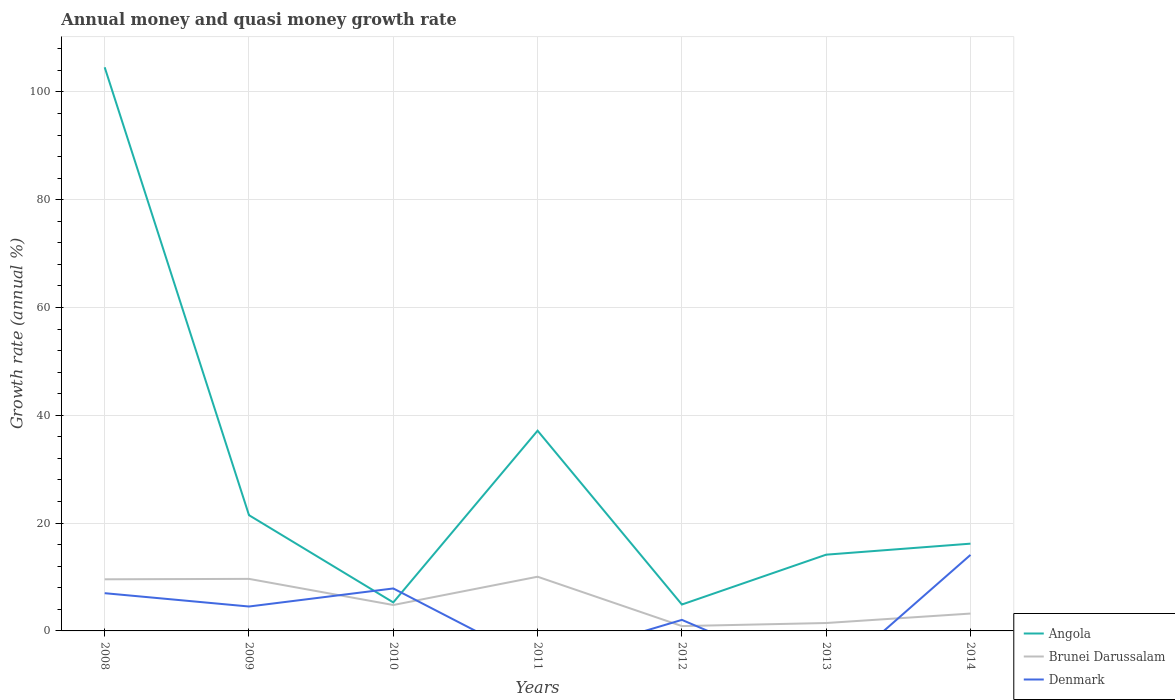Does the line corresponding to Brunei Darussalam intersect with the line corresponding to Angola?
Offer a very short reply. No. Is the number of lines equal to the number of legend labels?
Make the answer very short. No. Across all years, what is the maximum growth rate in Brunei Darussalam?
Your response must be concise. 0.9. What is the total growth rate in Angola in the graph?
Give a very brief answer. -11.29. What is the difference between the highest and the second highest growth rate in Brunei Darussalam?
Provide a short and direct response. 9.16. Is the growth rate in Denmark strictly greater than the growth rate in Angola over the years?
Provide a succinct answer. No. Does the graph contain any zero values?
Keep it short and to the point. Yes. Does the graph contain grids?
Keep it short and to the point. Yes. How are the legend labels stacked?
Offer a very short reply. Vertical. What is the title of the graph?
Offer a terse response. Annual money and quasi money growth rate. Does "Ukraine" appear as one of the legend labels in the graph?
Give a very brief answer. No. What is the label or title of the Y-axis?
Keep it short and to the point. Growth rate (annual %). What is the Growth rate (annual %) in Angola in 2008?
Provide a short and direct response. 104.57. What is the Growth rate (annual %) in Brunei Darussalam in 2008?
Your answer should be compact. 9.58. What is the Growth rate (annual %) in Denmark in 2008?
Provide a short and direct response. 7. What is the Growth rate (annual %) of Angola in 2009?
Offer a terse response. 21.48. What is the Growth rate (annual %) of Brunei Darussalam in 2009?
Make the answer very short. 9.66. What is the Growth rate (annual %) in Denmark in 2009?
Your answer should be compact. 4.53. What is the Growth rate (annual %) of Angola in 2010?
Offer a terse response. 5.29. What is the Growth rate (annual %) in Brunei Darussalam in 2010?
Keep it short and to the point. 4.81. What is the Growth rate (annual %) in Denmark in 2010?
Your answer should be compact. 7.88. What is the Growth rate (annual %) in Angola in 2011?
Offer a terse response. 37.15. What is the Growth rate (annual %) of Brunei Darussalam in 2011?
Your answer should be very brief. 10.05. What is the Growth rate (annual %) in Angola in 2012?
Your answer should be compact. 4.9. What is the Growth rate (annual %) in Brunei Darussalam in 2012?
Your response must be concise. 0.9. What is the Growth rate (annual %) in Denmark in 2012?
Your response must be concise. 2.05. What is the Growth rate (annual %) in Angola in 2013?
Offer a terse response. 14.15. What is the Growth rate (annual %) in Brunei Darussalam in 2013?
Provide a short and direct response. 1.47. What is the Growth rate (annual %) of Denmark in 2013?
Give a very brief answer. 0. What is the Growth rate (annual %) in Angola in 2014?
Ensure brevity in your answer.  16.19. What is the Growth rate (annual %) in Brunei Darussalam in 2014?
Provide a succinct answer. 3.22. What is the Growth rate (annual %) in Denmark in 2014?
Your answer should be compact. 14.1. Across all years, what is the maximum Growth rate (annual %) of Angola?
Your answer should be very brief. 104.57. Across all years, what is the maximum Growth rate (annual %) in Brunei Darussalam?
Ensure brevity in your answer.  10.05. Across all years, what is the maximum Growth rate (annual %) of Denmark?
Offer a very short reply. 14.1. Across all years, what is the minimum Growth rate (annual %) of Angola?
Your answer should be compact. 4.9. Across all years, what is the minimum Growth rate (annual %) of Brunei Darussalam?
Keep it short and to the point. 0.9. Across all years, what is the minimum Growth rate (annual %) of Denmark?
Give a very brief answer. 0. What is the total Growth rate (annual %) in Angola in the graph?
Offer a terse response. 203.71. What is the total Growth rate (annual %) in Brunei Darussalam in the graph?
Your response must be concise. 39.68. What is the total Growth rate (annual %) of Denmark in the graph?
Provide a short and direct response. 35.56. What is the difference between the Growth rate (annual %) in Angola in 2008 and that in 2009?
Offer a terse response. 83.09. What is the difference between the Growth rate (annual %) of Brunei Darussalam in 2008 and that in 2009?
Your answer should be compact. -0.08. What is the difference between the Growth rate (annual %) of Denmark in 2008 and that in 2009?
Your response must be concise. 2.47. What is the difference between the Growth rate (annual %) of Angola in 2008 and that in 2010?
Offer a terse response. 99.28. What is the difference between the Growth rate (annual %) in Brunei Darussalam in 2008 and that in 2010?
Offer a very short reply. 4.77. What is the difference between the Growth rate (annual %) of Denmark in 2008 and that in 2010?
Provide a succinct answer. -0.88. What is the difference between the Growth rate (annual %) in Angola in 2008 and that in 2011?
Offer a terse response. 67.42. What is the difference between the Growth rate (annual %) in Brunei Darussalam in 2008 and that in 2011?
Provide a succinct answer. -0.48. What is the difference between the Growth rate (annual %) in Angola in 2008 and that in 2012?
Offer a terse response. 99.67. What is the difference between the Growth rate (annual %) of Brunei Darussalam in 2008 and that in 2012?
Provide a succinct answer. 8.68. What is the difference between the Growth rate (annual %) in Denmark in 2008 and that in 2012?
Ensure brevity in your answer.  4.95. What is the difference between the Growth rate (annual %) in Angola in 2008 and that in 2013?
Your response must be concise. 90.42. What is the difference between the Growth rate (annual %) in Brunei Darussalam in 2008 and that in 2013?
Your answer should be very brief. 8.11. What is the difference between the Growth rate (annual %) in Angola in 2008 and that in 2014?
Give a very brief answer. 88.38. What is the difference between the Growth rate (annual %) of Brunei Darussalam in 2008 and that in 2014?
Keep it short and to the point. 6.36. What is the difference between the Growth rate (annual %) of Denmark in 2008 and that in 2014?
Give a very brief answer. -7.1. What is the difference between the Growth rate (annual %) of Angola in 2009 and that in 2010?
Ensure brevity in your answer.  16.19. What is the difference between the Growth rate (annual %) in Brunei Darussalam in 2009 and that in 2010?
Offer a very short reply. 4.85. What is the difference between the Growth rate (annual %) of Denmark in 2009 and that in 2010?
Provide a succinct answer. -3.35. What is the difference between the Growth rate (annual %) in Angola in 2009 and that in 2011?
Offer a very short reply. -15.67. What is the difference between the Growth rate (annual %) of Brunei Darussalam in 2009 and that in 2011?
Keep it short and to the point. -0.4. What is the difference between the Growth rate (annual %) of Angola in 2009 and that in 2012?
Provide a succinct answer. 16.58. What is the difference between the Growth rate (annual %) in Brunei Darussalam in 2009 and that in 2012?
Keep it short and to the point. 8.76. What is the difference between the Growth rate (annual %) of Denmark in 2009 and that in 2012?
Your response must be concise. 2.48. What is the difference between the Growth rate (annual %) of Angola in 2009 and that in 2013?
Your response must be concise. 7.33. What is the difference between the Growth rate (annual %) of Brunei Darussalam in 2009 and that in 2013?
Your answer should be very brief. 8.19. What is the difference between the Growth rate (annual %) in Angola in 2009 and that in 2014?
Ensure brevity in your answer.  5.29. What is the difference between the Growth rate (annual %) in Brunei Darussalam in 2009 and that in 2014?
Offer a terse response. 6.43. What is the difference between the Growth rate (annual %) in Denmark in 2009 and that in 2014?
Give a very brief answer. -9.57. What is the difference between the Growth rate (annual %) in Angola in 2010 and that in 2011?
Provide a succinct answer. -31.86. What is the difference between the Growth rate (annual %) of Brunei Darussalam in 2010 and that in 2011?
Give a very brief answer. -5.25. What is the difference between the Growth rate (annual %) of Angola in 2010 and that in 2012?
Provide a succinct answer. 0.39. What is the difference between the Growth rate (annual %) of Brunei Darussalam in 2010 and that in 2012?
Provide a short and direct response. 3.91. What is the difference between the Growth rate (annual %) in Denmark in 2010 and that in 2012?
Give a very brief answer. 5.83. What is the difference between the Growth rate (annual %) of Angola in 2010 and that in 2013?
Offer a terse response. -8.86. What is the difference between the Growth rate (annual %) in Brunei Darussalam in 2010 and that in 2013?
Your response must be concise. 3.34. What is the difference between the Growth rate (annual %) in Angola in 2010 and that in 2014?
Offer a very short reply. -10.9. What is the difference between the Growth rate (annual %) of Brunei Darussalam in 2010 and that in 2014?
Your answer should be very brief. 1.59. What is the difference between the Growth rate (annual %) in Denmark in 2010 and that in 2014?
Ensure brevity in your answer.  -6.22. What is the difference between the Growth rate (annual %) of Angola in 2011 and that in 2012?
Ensure brevity in your answer.  32.25. What is the difference between the Growth rate (annual %) in Brunei Darussalam in 2011 and that in 2012?
Your response must be concise. 9.16. What is the difference between the Growth rate (annual %) of Angola in 2011 and that in 2013?
Your response must be concise. 23. What is the difference between the Growth rate (annual %) of Brunei Darussalam in 2011 and that in 2013?
Your answer should be very brief. 8.59. What is the difference between the Growth rate (annual %) in Angola in 2011 and that in 2014?
Give a very brief answer. 20.96. What is the difference between the Growth rate (annual %) of Brunei Darussalam in 2011 and that in 2014?
Your answer should be very brief. 6.83. What is the difference between the Growth rate (annual %) of Angola in 2012 and that in 2013?
Give a very brief answer. -9.25. What is the difference between the Growth rate (annual %) in Brunei Darussalam in 2012 and that in 2013?
Provide a succinct answer. -0.57. What is the difference between the Growth rate (annual %) in Angola in 2012 and that in 2014?
Give a very brief answer. -11.29. What is the difference between the Growth rate (annual %) of Brunei Darussalam in 2012 and that in 2014?
Your answer should be very brief. -2.32. What is the difference between the Growth rate (annual %) of Denmark in 2012 and that in 2014?
Your answer should be very brief. -12.05. What is the difference between the Growth rate (annual %) in Angola in 2013 and that in 2014?
Offer a terse response. -2.04. What is the difference between the Growth rate (annual %) in Brunei Darussalam in 2013 and that in 2014?
Provide a succinct answer. -1.75. What is the difference between the Growth rate (annual %) in Angola in 2008 and the Growth rate (annual %) in Brunei Darussalam in 2009?
Ensure brevity in your answer.  94.91. What is the difference between the Growth rate (annual %) of Angola in 2008 and the Growth rate (annual %) of Denmark in 2009?
Provide a short and direct response. 100.04. What is the difference between the Growth rate (annual %) of Brunei Darussalam in 2008 and the Growth rate (annual %) of Denmark in 2009?
Your answer should be very brief. 5.05. What is the difference between the Growth rate (annual %) in Angola in 2008 and the Growth rate (annual %) in Brunei Darussalam in 2010?
Your answer should be very brief. 99.76. What is the difference between the Growth rate (annual %) of Angola in 2008 and the Growth rate (annual %) of Denmark in 2010?
Provide a succinct answer. 96.69. What is the difference between the Growth rate (annual %) in Brunei Darussalam in 2008 and the Growth rate (annual %) in Denmark in 2010?
Offer a very short reply. 1.7. What is the difference between the Growth rate (annual %) in Angola in 2008 and the Growth rate (annual %) in Brunei Darussalam in 2011?
Give a very brief answer. 94.51. What is the difference between the Growth rate (annual %) in Angola in 2008 and the Growth rate (annual %) in Brunei Darussalam in 2012?
Provide a succinct answer. 103.67. What is the difference between the Growth rate (annual %) of Angola in 2008 and the Growth rate (annual %) of Denmark in 2012?
Ensure brevity in your answer.  102.52. What is the difference between the Growth rate (annual %) of Brunei Darussalam in 2008 and the Growth rate (annual %) of Denmark in 2012?
Keep it short and to the point. 7.53. What is the difference between the Growth rate (annual %) in Angola in 2008 and the Growth rate (annual %) in Brunei Darussalam in 2013?
Offer a very short reply. 103.1. What is the difference between the Growth rate (annual %) of Angola in 2008 and the Growth rate (annual %) of Brunei Darussalam in 2014?
Your answer should be very brief. 101.34. What is the difference between the Growth rate (annual %) of Angola in 2008 and the Growth rate (annual %) of Denmark in 2014?
Provide a succinct answer. 90.46. What is the difference between the Growth rate (annual %) in Brunei Darussalam in 2008 and the Growth rate (annual %) in Denmark in 2014?
Your answer should be compact. -4.52. What is the difference between the Growth rate (annual %) in Angola in 2009 and the Growth rate (annual %) in Brunei Darussalam in 2010?
Make the answer very short. 16.67. What is the difference between the Growth rate (annual %) in Angola in 2009 and the Growth rate (annual %) in Denmark in 2010?
Your answer should be very brief. 13.6. What is the difference between the Growth rate (annual %) of Brunei Darussalam in 2009 and the Growth rate (annual %) of Denmark in 2010?
Your response must be concise. 1.78. What is the difference between the Growth rate (annual %) of Angola in 2009 and the Growth rate (annual %) of Brunei Darussalam in 2011?
Ensure brevity in your answer.  11.42. What is the difference between the Growth rate (annual %) in Angola in 2009 and the Growth rate (annual %) in Brunei Darussalam in 2012?
Make the answer very short. 20.58. What is the difference between the Growth rate (annual %) in Angola in 2009 and the Growth rate (annual %) in Denmark in 2012?
Your response must be concise. 19.43. What is the difference between the Growth rate (annual %) of Brunei Darussalam in 2009 and the Growth rate (annual %) of Denmark in 2012?
Offer a very short reply. 7.61. What is the difference between the Growth rate (annual %) in Angola in 2009 and the Growth rate (annual %) in Brunei Darussalam in 2013?
Provide a short and direct response. 20.01. What is the difference between the Growth rate (annual %) of Angola in 2009 and the Growth rate (annual %) of Brunei Darussalam in 2014?
Give a very brief answer. 18.25. What is the difference between the Growth rate (annual %) in Angola in 2009 and the Growth rate (annual %) in Denmark in 2014?
Make the answer very short. 7.37. What is the difference between the Growth rate (annual %) of Brunei Darussalam in 2009 and the Growth rate (annual %) of Denmark in 2014?
Provide a succinct answer. -4.45. What is the difference between the Growth rate (annual %) in Angola in 2010 and the Growth rate (annual %) in Brunei Darussalam in 2011?
Offer a very short reply. -4.77. What is the difference between the Growth rate (annual %) of Angola in 2010 and the Growth rate (annual %) of Brunei Darussalam in 2012?
Make the answer very short. 4.39. What is the difference between the Growth rate (annual %) of Angola in 2010 and the Growth rate (annual %) of Denmark in 2012?
Your response must be concise. 3.24. What is the difference between the Growth rate (annual %) of Brunei Darussalam in 2010 and the Growth rate (annual %) of Denmark in 2012?
Offer a terse response. 2.76. What is the difference between the Growth rate (annual %) of Angola in 2010 and the Growth rate (annual %) of Brunei Darussalam in 2013?
Offer a very short reply. 3.82. What is the difference between the Growth rate (annual %) of Angola in 2010 and the Growth rate (annual %) of Brunei Darussalam in 2014?
Keep it short and to the point. 2.07. What is the difference between the Growth rate (annual %) of Angola in 2010 and the Growth rate (annual %) of Denmark in 2014?
Keep it short and to the point. -8.82. What is the difference between the Growth rate (annual %) in Brunei Darussalam in 2010 and the Growth rate (annual %) in Denmark in 2014?
Keep it short and to the point. -9.3. What is the difference between the Growth rate (annual %) of Angola in 2011 and the Growth rate (annual %) of Brunei Darussalam in 2012?
Keep it short and to the point. 36.25. What is the difference between the Growth rate (annual %) in Angola in 2011 and the Growth rate (annual %) in Denmark in 2012?
Give a very brief answer. 35.1. What is the difference between the Growth rate (annual %) in Brunei Darussalam in 2011 and the Growth rate (annual %) in Denmark in 2012?
Offer a very short reply. 8.01. What is the difference between the Growth rate (annual %) in Angola in 2011 and the Growth rate (annual %) in Brunei Darussalam in 2013?
Your answer should be very brief. 35.68. What is the difference between the Growth rate (annual %) in Angola in 2011 and the Growth rate (annual %) in Brunei Darussalam in 2014?
Keep it short and to the point. 33.93. What is the difference between the Growth rate (annual %) in Angola in 2011 and the Growth rate (annual %) in Denmark in 2014?
Give a very brief answer. 23.04. What is the difference between the Growth rate (annual %) of Brunei Darussalam in 2011 and the Growth rate (annual %) of Denmark in 2014?
Provide a succinct answer. -4.05. What is the difference between the Growth rate (annual %) in Angola in 2012 and the Growth rate (annual %) in Brunei Darussalam in 2013?
Your response must be concise. 3.43. What is the difference between the Growth rate (annual %) of Angola in 2012 and the Growth rate (annual %) of Brunei Darussalam in 2014?
Your answer should be very brief. 1.68. What is the difference between the Growth rate (annual %) in Angola in 2012 and the Growth rate (annual %) in Denmark in 2014?
Ensure brevity in your answer.  -9.21. What is the difference between the Growth rate (annual %) in Brunei Darussalam in 2012 and the Growth rate (annual %) in Denmark in 2014?
Your answer should be very brief. -13.2. What is the difference between the Growth rate (annual %) in Angola in 2013 and the Growth rate (annual %) in Brunei Darussalam in 2014?
Your response must be concise. 10.93. What is the difference between the Growth rate (annual %) in Angola in 2013 and the Growth rate (annual %) in Denmark in 2014?
Ensure brevity in your answer.  0.04. What is the difference between the Growth rate (annual %) of Brunei Darussalam in 2013 and the Growth rate (annual %) of Denmark in 2014?
Keep it short and to the point. -12.64. What is the average Growth rate (annual %) in Angola per year?
Keep it short and to the point. 29.1. What is the average Growth rate (annual %) of Brunei Darussalam per year?
Provide a succinct answer. 5.67. What is the average Growth rate (annual %) in Denmark per year?
Ensure brevity in your answer.  5.08. In the year 2008, what is the difference between the Growth rate (annual %) of Angola and Growth rate (annual %) of Brunei Darussalam?
Ensure brevity in your answer.  94.99. In the year 2008, what is the difference between the Growth rate (annual %) in Angola and Growth rate (annual %) in Denmark?
Your answer should be very brief. 97.57. In the year 2008, what is the difference between the Growth rate (annual %) of Brunei Darussalam and Growth rate (annual %) of Denmark?
Provide a succinct answer. 2.58. In the year 2009, what is the difference between the Growth rate (annual %) in Angola and Growth rate (annual %) in Brunei Darussalam?
Provide a succinct answer. 11.82. In the year 2009, what is the difference between the Growth rate (annual %) of Angola and Growth rate (annual %) of Denmark?
Your answer should be very brief. 16.95. In the year 2009, what is the difference between the Growth rate (annual %) of Brunei Darussalam and Growth rate (annual %) of Denmark?
Your response must be concise. 5.13. In the year 2010, what is the difference between the Growth rate (annual %) of Angola and Growth rate (annual %) of Brunei Darussalam?
Keep it short and to the point. 0.48. In the year 2010, what is the difference between the Growth rate (annual %) of Angola and Growth rate (annual %) of Denmark?
Ensure brevity in your answer.  -2.59. In the year 2010, what is the difference between the Growth rate (annual %) in Brunei Darussalam and Growth rate (annual %) in Denmark?
Your answer should be compact. -3.07. In the year 2011, what is the difference between the Growth rate (annual %) in Angola and Growth rate (annual %) in Brunei Darussalam?
Your answer should be very brief. 27.09. In the year 2012, what is the difference between the Growth rate (annual %) of Angola and Growth rate (annual %) of Brunei Darussalam?
Ensure brevity in your answer.  4. In the year 2012, what is the difference between the Growth rate (annual %) of Angola and Growth rate (annual %) of Denmark?
Provide a succinct answer. 2.85. In the year 2012, what is the difference between the Growth rate (annual %) in Brunei Darussalam and Growth rate (annual %) in Denmark?
Provide a succinct answer. -1.15. In the year 2013, what is the difference between the Growth rate (annual %) of Angola and Growth rate (annual %) of Brunei Darussalam?
Give a very brief answer. 12.68. In the year 2014, what is the difference between the Growth rate (annual %) in Angola and Growth rate (annual %) in Brunei Darussalam?
Your answer should be very brief. 12.97. In the year 2014, what is the difference between the Growth rate (annual %) in Angola and Growth rate (annual %) in Denmark?
Your answer should be very brief. 2.09. In the year 2014, what is the difference between the Growth rate (annual %) of Brunei Darussalam and Growth rate (annual %) of Denmark?
Give a very brief answer. -10.88. What is the ratio of the Growth rate (annual %) of Angola in 2008 to that in 2009?
Make the answer very short. 4.87. What is the ratio of the Growth rate (annual %) of Brunei Darussalam in 2008 to that in 2009?
Offer a very short reply. 0.99. What is the ratio of the Growth rate (annual %) in Denmark in 2008 to that in 2009?
Your answer should be very brief. 1.55. What is the ratio of the Growth rate (annual %) in Angola in 2008 to that in 2010?
Offer a very short reply. 19.77. What is the ratio of the Growth rate (annual %) in Brunei Darussalam in 2008 to that in 2010?
Your response must be concise. 1.99. What is the ratio of the Growth rate (annual %) of Denmark in 2008 to that in 2010?
Offer a terse response. 0.89. What is the ratio of the Growth rate (annual %) in Angola in 2008 to that in 2011?
Make the answer very short. 2.81. What is the ratio of the Growth rate (annual %) of Brunei Darussalam in 2008 to that in 2011?
Make the answer very short. 0.95. What is the ratio of the Growth rate (annual %) of Angola in 2008 to that in 2012?
Ensure brevity in your answer.  21.35. What is the ratio of the Growth rate (annual %) of Brunei Darussalam in 2008 to that in 2012?
Provide a short and direct response. 10.65. What is the ratio of the Growth rate (annual %) in Denmark in 2008 to that in 2012?
Give a very brief answer. 3.42. What is the ratio of the Growth rate (annual %) of Angola in 2008 to that in 2013?
Offer a very short reply. 7.39. What is the ratio of the Growth rate (annual %) in Brunei Darussalam in 2008 to that in 2013?
Provide a succinct answer. 6.53. What is the ratio of the Growth rate (annual %) of Angola in 2008 to that in 2014?
Your answer should be very brief. 6.46. What is the ratio of the Growth rate (annual %) in Brunei Darussalam in 2008 to that in 2014?
Provide a short and direct response. 2.97. What is the ratio of the Growth rate (annual %) of Denmark in 2008 to that in 2014?
Make the answer very short. 0.5. What is the ratio of the Growth rate (annual %) in Angola in 2009 to that in 2010?
Provide a short and direct response. 4.06. What is the ratio of the Growth rate (annual %) in Brunei Darussalam in 2009 to that in 2010?
Offer a terse response. 2.01. What is the ratio of the Growth rate (annual %) in Denmark in 2009 to that in 2010?
Provide a succinct answer. 0.57. What is the ratio of the Growth rate (annual %) of Angola in 2009 to that in 2011?
Your response must be concise. 0.58. What is the ratio of the Growth rate (annual %) of Brunei Darussalam in 2009 to that in 2011?
Give a very brief answer. 0.96. What is the ratio of the Growth rate (annual %) of Angola in 2009 to that in 2012?
Keep it short and to the point. 4.38. What is the ratio of the Growth rate (annual %) in Brunei Darussalam in 2009 to that in 2012?
Your answer should be compact. 10.74. What is the ratio of the Growth rate (annual %) in Denmark in 2009 to that in 2012?
Your response must be concise. 2.21. What is the ratio of the Growth rate (annual %) in Angola in 2009 to that in 2013?
Offer a very short reply. 1.52. What is the ratio of the Growth rate (annual %) in Brunei Darussalam in 2009 to that in 2013?
Provide a short and direct response. 6.59. What is the ratio of the Growth rate (annual %) in Angola in 2009 to that in 2014?
Your answer should be very brief. 1.33. What is the ratio of the Growth rate (annual %) in Brunei Darussalam in 2009 to that in 2014?
Your answer should be compact. 3. What is the ratio of the Growth rate (annual %) in Denmark in 2009 to that in 2014?
Provide a succinct answer. 0.32. What is the ratio of the Growth rate (annual %) in Angola in 2010 to that in 2011?
Your response must be concise. 0.14. What is the ratio of the Growth rate (annual %) in Brunei Darussalam in 2010 to that in 2011?
Offer a terse response. 0.48. What is the ratio of the Growth rate (annual %) in Angola in 2010 to that in 2012?
Make the answer very short. 1.08. What is the ratio of the Growth rate (annual %) in Brunei Darussalam in 2010 to that in 2012?
Give a very brief answer. 5.35. What is the ratio of the Growth rate (annual %) of Denmark in 2010 to that in 2012?
Your answer should be very brief. 3.85. What is the ratio of the Growth rate (annual %) in Angola in 2010 to that in 2013?
Give a very brief answer. 0.37. What is the ratio of the Growth rate (annual %) in Brunei Darussalam in 2010 to that in 2013?
Make the answer very short. 3.28. What is the ratio of the Growth rate (annual %) of Angola in 2010 to that in 2014?
Ensure brevity in your answer.  0.33. What is the ratio of the Growth rate (annual %) of Brunei Darussalam in 2010 to that in 2014?
Your response must be concise. 1.49. What is the ratio of the Growth rate (annual %) in Denmark in 2010 to that in 2014?
Give a very brief answer. 0.56. What is the ratio of the Growth rate (annual %) of Angola in 2011 to that in 2012?
Provide a short and direct response. 7.58. What is the ratio of the Growth rate (annual %) in Brunei Darussalam in 2011 to that in 2012?
Make the answer very short. 11.18. What is the ratio of the Growth rate (annual %) in Angola in 2011 to that in 2013?
Your response must be concise. 2.63. What is the ratio of the Growth rate (annual %) of Brunei Darussalam in 2011 to that in 2013?
Ensure brevity in your answer.  6.86. What is the ratio of the Growth rate (annual %) in Angola in 2011 to that in 2014?
Ensure brevity in your answer.  2.29. What is the ratio of the Growth rate (annual %) of Brunei Darussalam in 2011 to that in 2014?
Provide a short and direct response. 3.12. What is the ratio of the Growth rate (annual %) in Angola in 2012 to that in 2013?
Provide a succinct answer. 0.35. What is the ratio of the Growth rate (annual %) in Brunei Darussalam in 2012 to that in 2013?
Your answer should be compact. 0.61. What is the ratio of the Growth rate (annual %) of Angola in 2012 to that in 2014?
Offer a terse response. 0.3. What is the ratio of the Growth rate (annual %) of Brunei Darussalam in 2012 to that in 2014?
Offer a very short reply. 0.28. What is the ratio of the Growth rate (annual %) in Denmark in 2012 to that in 2014?
Your answer should be very brief. 0.15. What is the ratio of the Growth rate (annual %) of Angola in 2013 to that in 2014?
Provide a succinct answer. 0.87. What is the ratio of the Growth rate (annual %) of Brunei Darussalam in 2013 to that in 2014?
Provide a short and direct response. 0.46. What is the difference between the highest and the second highest Growth rate (annual %) of Angola?
Offer a terse response. 67.42. What is the difference between the highest and the second highest Growth rate (annual %) of Brunei Darussalam?
Make the answer very short. 0.4. What is the difference between the highest and the second highest Growth rate (annual %) of Denmark?
Your answer should be very brief. 6.22. What is the difference between the highest and the lowest Growth rate (annual %) of Angola?
Provide a short and direct response. 99.67. What is the difference between the highest and the lowest Growth rate (annual %) in Brunei Darussalam?
Your response must be concise. 9.16. What is the difference between the highest and the lowest Growth rate (annual %) of Denmark?
Provide a succinct answer. 14.1. 